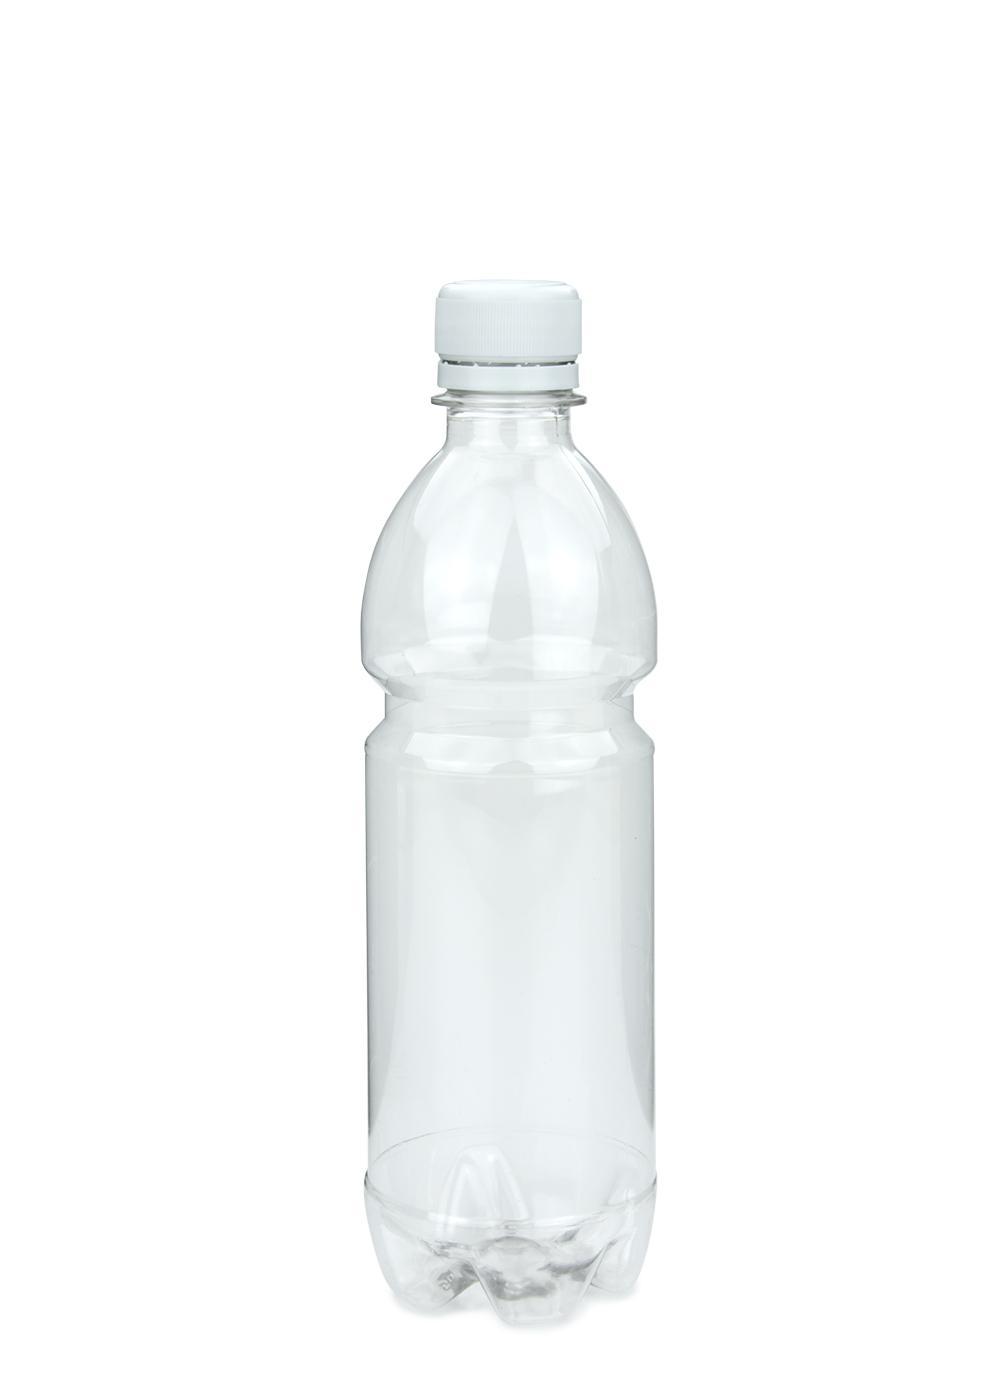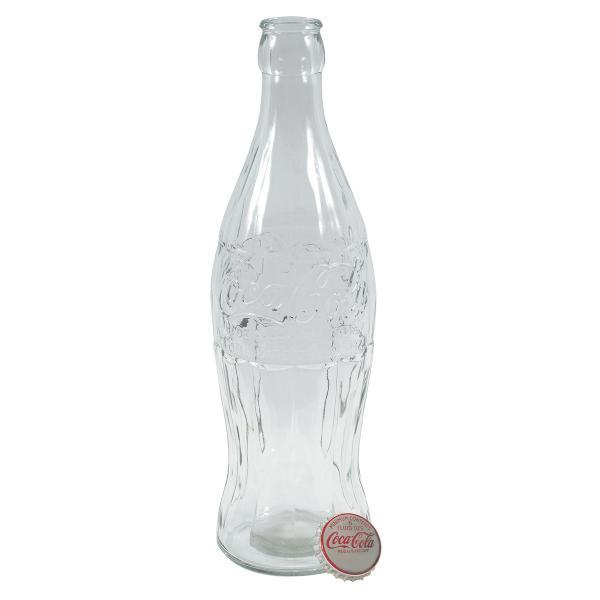The first image is the image on the left, the second image is the image on the right. Assess this claim about the two images: "One of the bottles comes with a lid.". Correct or not? Answer yes or no. Yes. The first image is the image on the left, the second image is the image on the right. For the images shown, is this caption "Each image shows one clear bottle, and the bottle on the left has a white lid on and is mostly cylindrical with at least one ribbed part, while the righthand bottle doesn't have its cap on." true? Answer yes or no. Yes. 